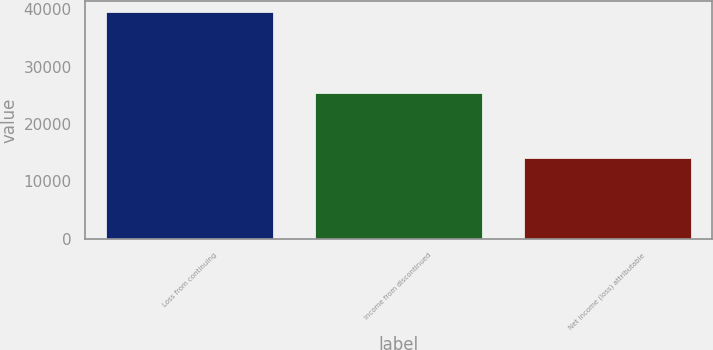Convert chart to OTSL. <chart><loc_0><loc_0><loc_500><loc_500><bar_chart><fcel>Loss from continuing<fcel>Income from discontinued<fcel>Net income (loss) attributable<nl><fcel>39448<fcel>25340<fcel>14108<nl></chart> 